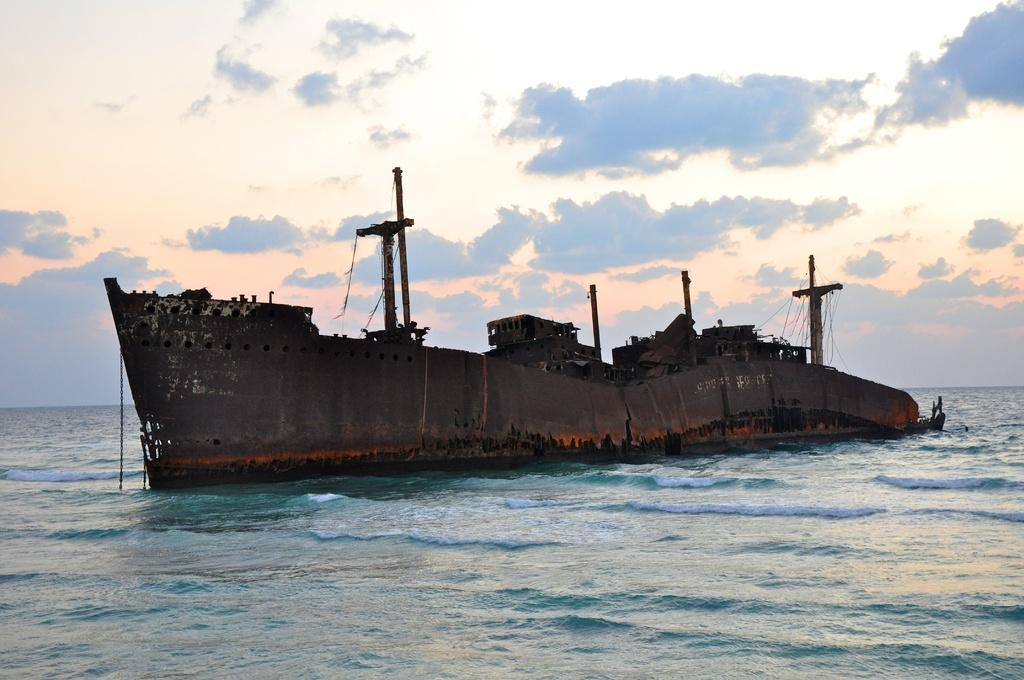What is the main subject in the center of the image? There is a ship in the center of the image. Where is the ship located? The ship is on the water. What can be seen in the background of the image? There is sky visible in the background of the image. How many fingers can be seen holding the ship in the image? There are no fingers visible in the image; the ship is on the water. What type of banana is growing on the ship in the image? There are no bananas present in the image; it features a ship on the water. 